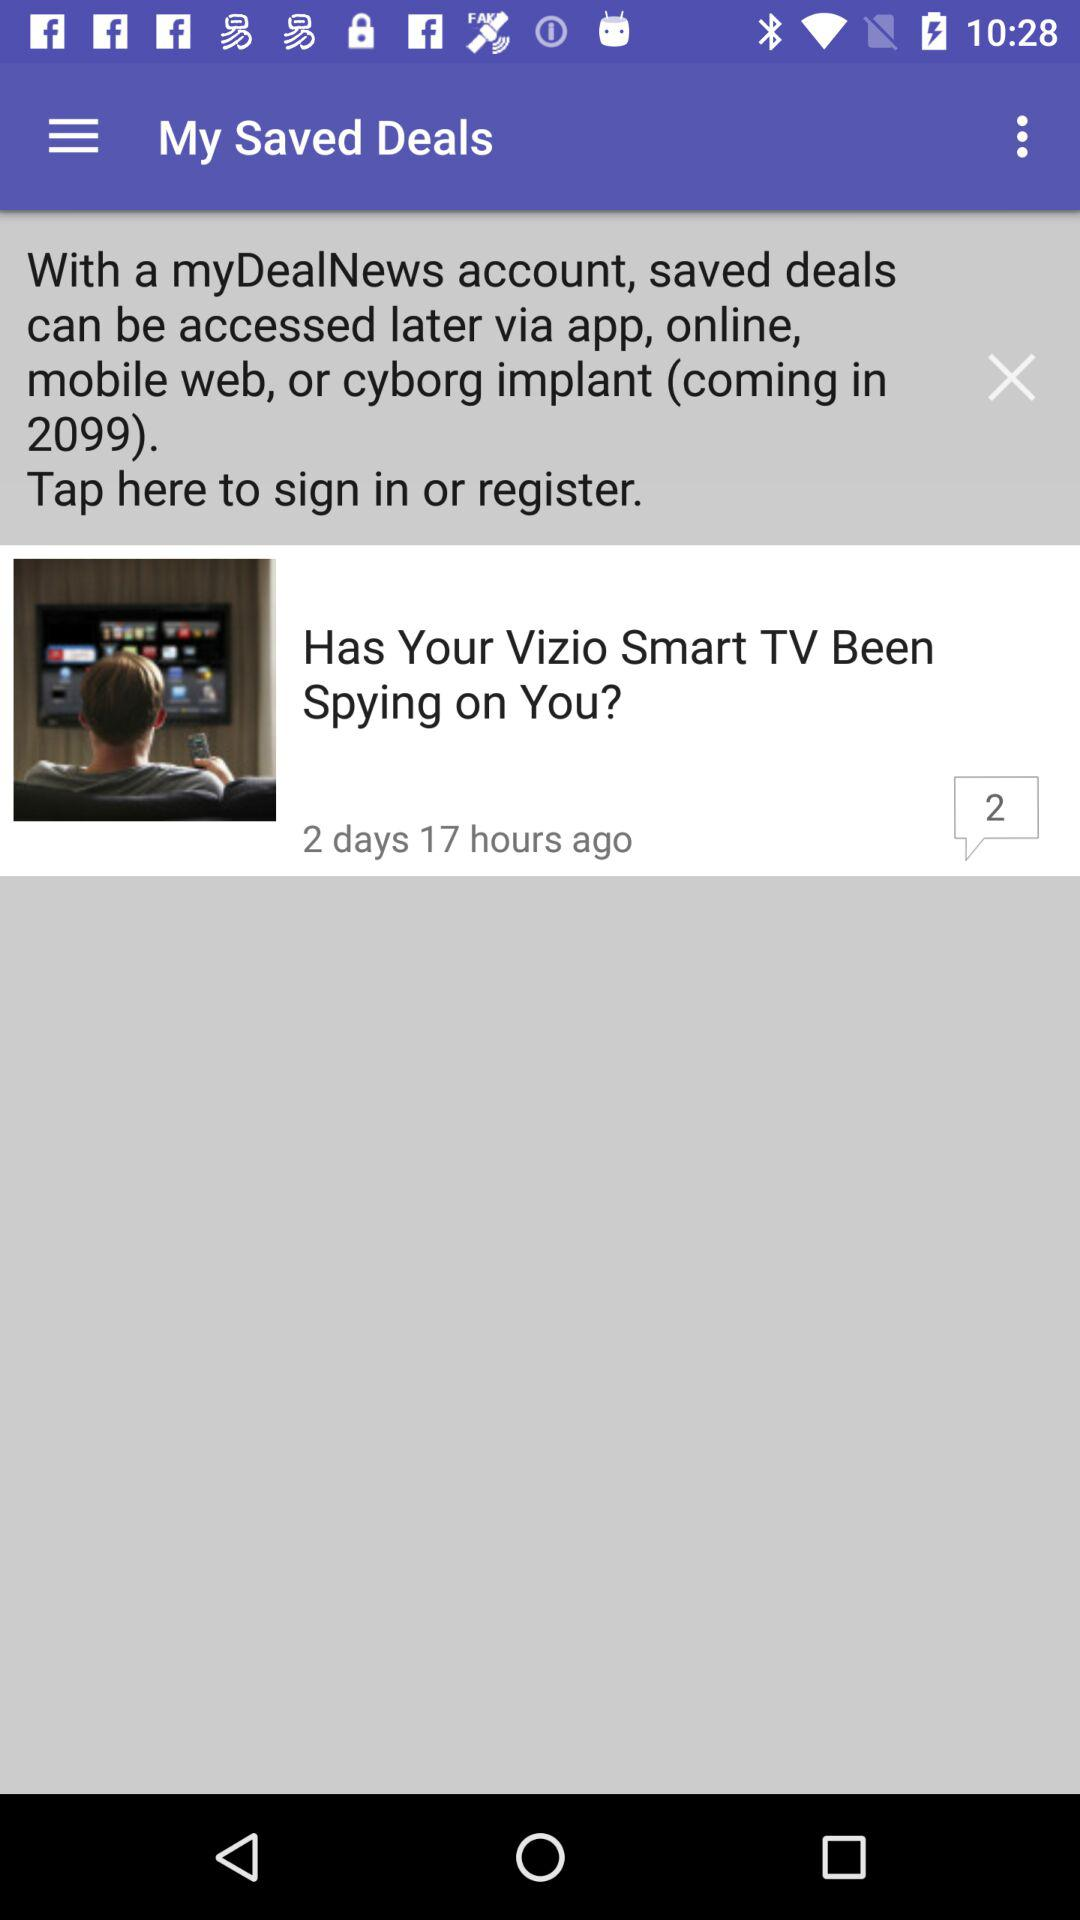By which medium can the saved deals be accessed? The saved deals can be accessed via the app, online, mobile web or cyborg implant. 